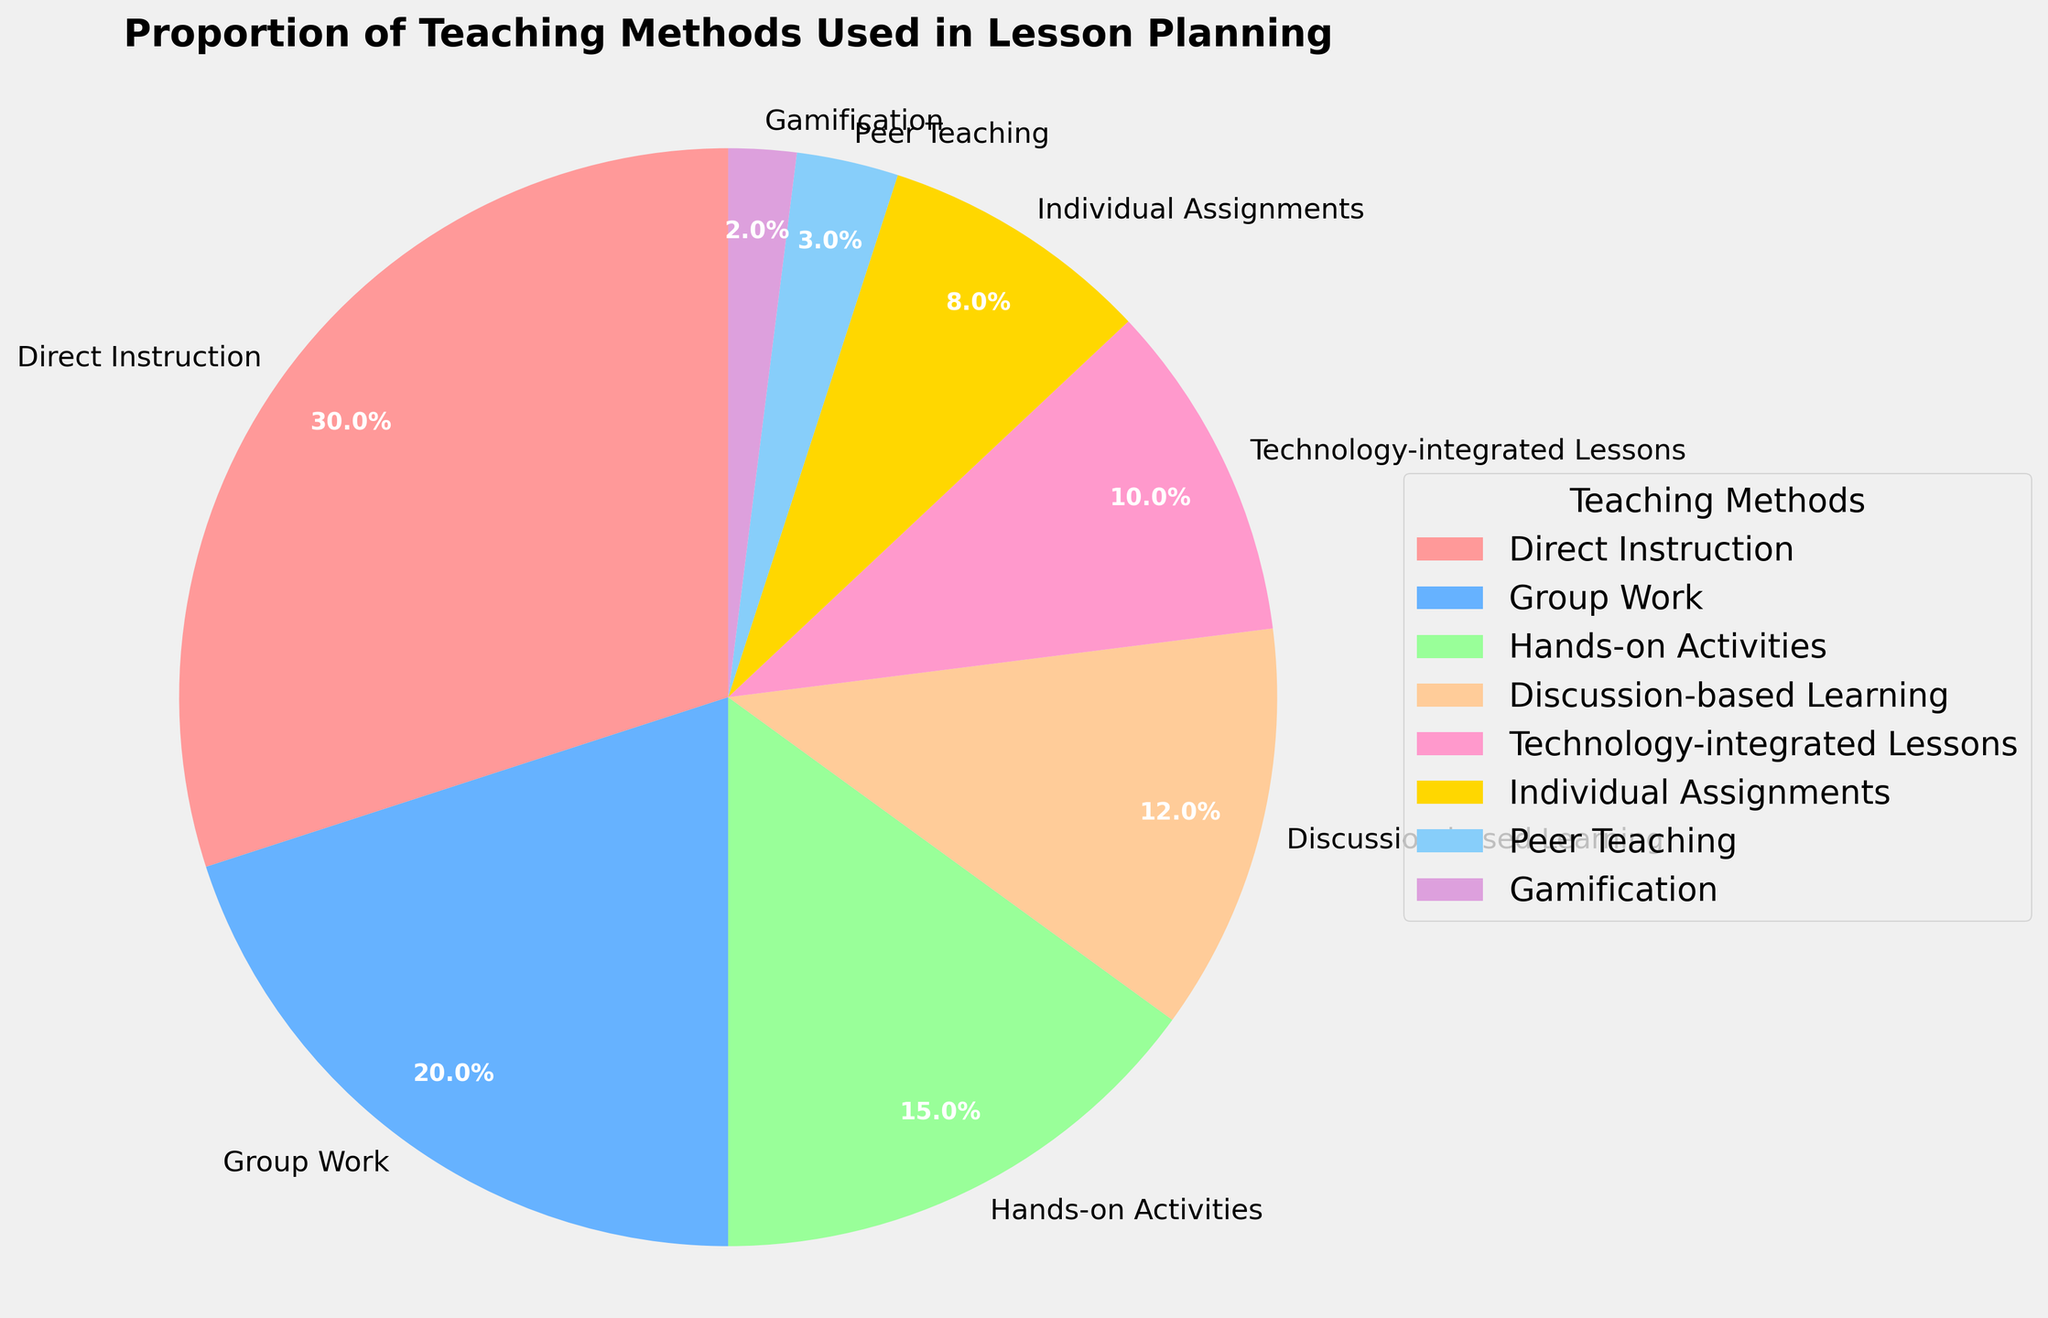What proportion of the lesson plans relies on Direct Instruction and Group Work combined? The proportion of Direct Instruction is 30%, and the proportion of Group Work is 20%. Adding them together gives 30% + 20% = 50%.
Answer: 50% Which teaching method is the least used in the lesson plans? From the chart, Gamification has the smallest percentage, which is 2%.
Answer: Gamification How much more is the proportion of Hands-on Activities compared to Technology-integrated Lessons? The proportion of Hands-on Activities is 15%, and Technology-integrated Lessons is 10%. The difference is 15% - 10% = 5%.
Answer: 5% Which teaching methods have a combined proportion of 23%? The teaching methods Discussion-based Learning and Individual Assignments have proportions of 12% and 8%, respectively. Their combined proportion is 12% + 8% = 20%. No single pair sums to 23%. Therefore, no exact combination results in 23%.
Answer: None What percentage of lesson plans do not involve Direct Instruction, Group Work, or Hands-on Activities? The combined percentage for Direct Instruction (30%), Group Work (20%), and Hands-on Activities (15%) is 30% + 20% + 15% = 65%. Subtracting from 100% gives 100% - 65% = 35%.
Answer: 35% Which teaching method has a greater proportion: Individual Assignments or Discussion-based Learning? According to the chart, Discussion-based Learning is 12%, while Individual Assignments is 8%. Since 12% is greater than 8%, Discussion-based Learning has a larger proportion.
Answer: Discussion-based Learning If you were to combine Technology-integrated Lessons with Peer Teaching, what is their total percentage? The proportion of Technology-integrated Lessons is 10%, and Peer Teaching is 3%. Adding them together gives 10% + 3% = 13%.
Answer: 13% What proportion of lesson plans involve Gamification compared to Individual Assignments? Individual Assignments account for 8%, and Gamification for 2%. Proportionally, Individual Assignments are 4 times (8/2) more used than Gamification.
Answer: 4 times How does the proportion of Group Work compare to Hands-on Activities? The proportion of Group Work is 20%, while Hands-on Activities is 15%. Group Work is 5% higher than Hands-on Activities.
Answer: 5% higher What combined proportion do Peer Teaching and Gamification represent in the lesson plans? The proportions for Peer Teaching and Gamification are 3% and 2%, respectively. Adding them together gives 3% + 2% = 5%.
Answer: 5% 